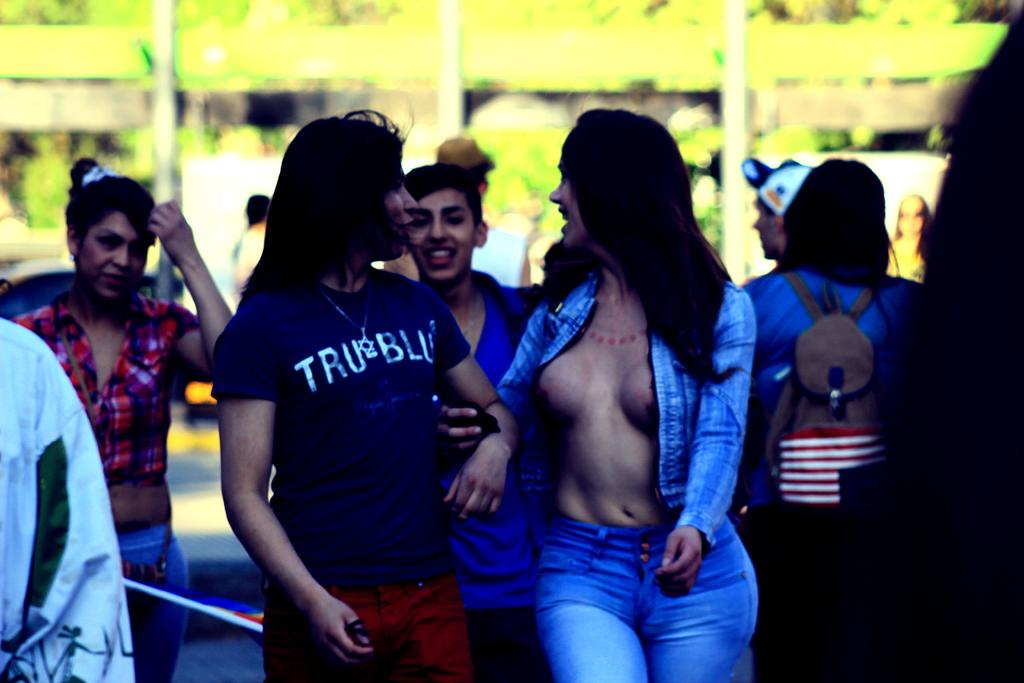What are the women in the image doing? The women in the image are standing and walking. Can you describe the background of the image? The background of the image is blurred. How many horses are present in the image? There are no horses present in the image; it only features women standing and walking. 